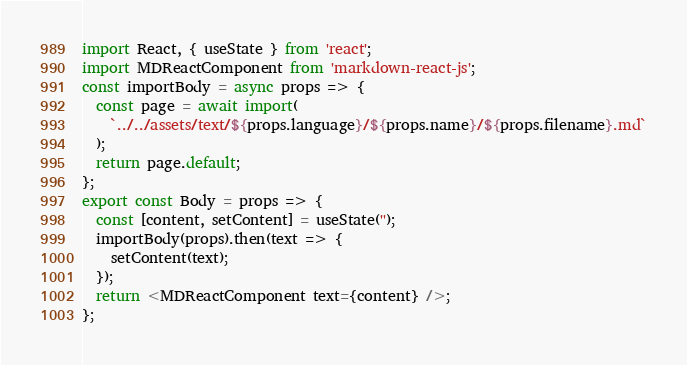Convert code to text. <code><loc_0><loc_0><loc_500><loc_500><_JavaScript_>import React, { useState } from 'react';
import MDReactComponent from 'markdown-react-js';
const importBody = async props => {
  const page = await import(
    `../../assets/text/${props.language}/${props.name}/${props.filename}.md`
  );
  return page.default;
};
export const Body = props => {
  const [content, setContent] = useState('');
  importBody(props).then(text => {
    setContent(text);
  });
  return <MDReactComponent text={content} />;
};
</code> 